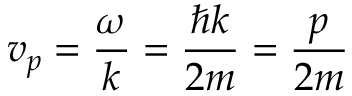Convert formula to latex. <formula><loc_0><loc_0><loc_500><loc_500>v _ { p } = { \frac { \omega } { k } } = { \frac { \hbar { k } } { 2 m } } = { \frac { p } { 2 m } }</formula> 